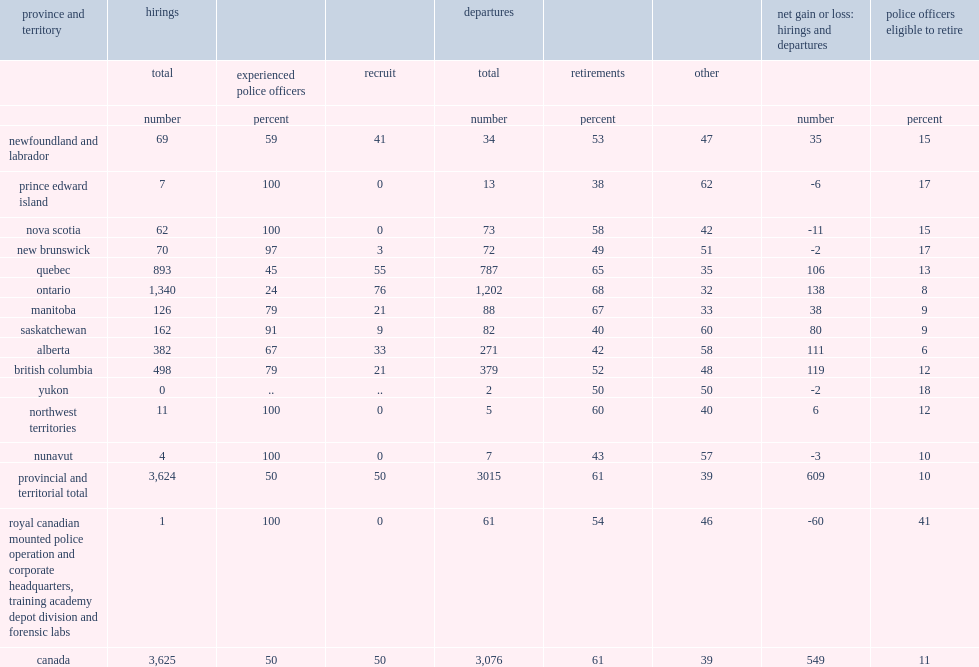What percentage of police officers in canada were eligible to retire? 11.0. 